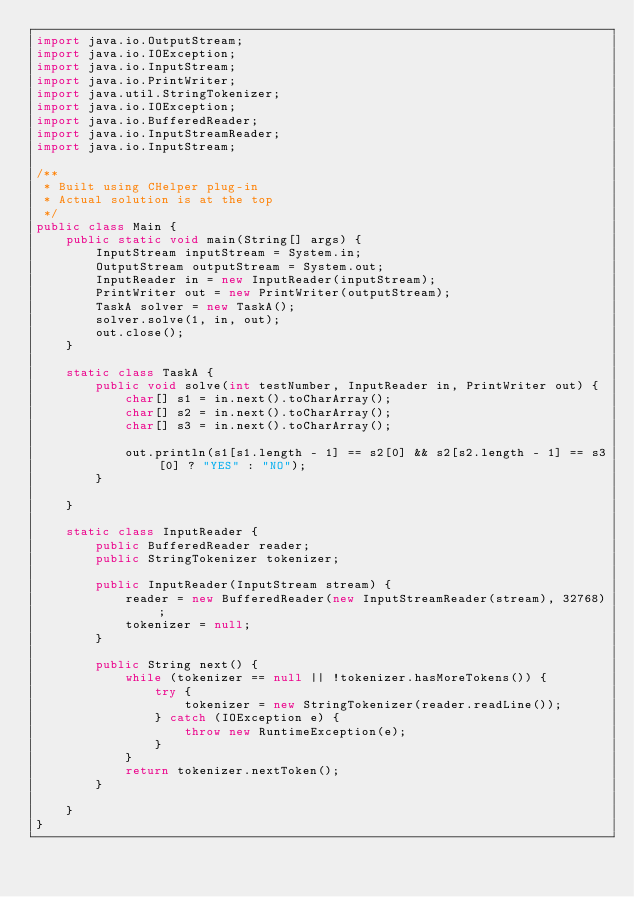Convert code to text. <code><loc_0><loc_0><loc_500><loc_500><_Java_>import java.io.OutputStream;
import java.io.IOException;
import java.io.InputStream;
import java.io.PrintWriter;
import java.util.StringTokenizer;
import java.io.IOException;
import java.io.BufferedReader;
import java.io.InputStreamReader;
import java.io.InputStream;

/**
 * Built using CHelper plug-in
 * Actual solution is at the top
 */
public class Main {
    public static void main(String[] args) {
        InputStream inputStream = System.in;
        OutputStream outputStream = System.out;
        InputReader in = new InputReader(inputStream);
        PrintWriter out = new PrintWriter(outputStream);
        TaskA solver = new TaskA();
        solver.solve(1, in, out);
        out.close();
    }

    static class TaskA {
        public void solve(int testNumber, InputReader in, PrintWriter out) {
            char[] s1 = in.next().toCharArray();
            char[] s2 = in.next().toCharArray();
            char[] s3 = in.next().toCharArray();

            out.println(s1[s1.length - 1] == s2[0] && s2[s2.length - 1] == s3[0] ? "YES" : "NO");
        }

    }

    static class InputReader {
        public BufferedReader reader;
        public StringTokenizer tokenizer;

        public InputReader(InputStream stream) {
            reader = new BufferedReader(new InputStreamReader(stream), 32768);
            tokenizer = null;
        }

        public String next() {
            while (tokenizer == null || !tokenizer.hasMoreTokens()) {
                try {
                    tokenizer = new StringTokenizer(reader.readLine());
                } catch (IOException e) {
                    throw new RuntimeException(e);
                }
            }
            return tokenizer.nextToken();
        }

    }
}

</code> 